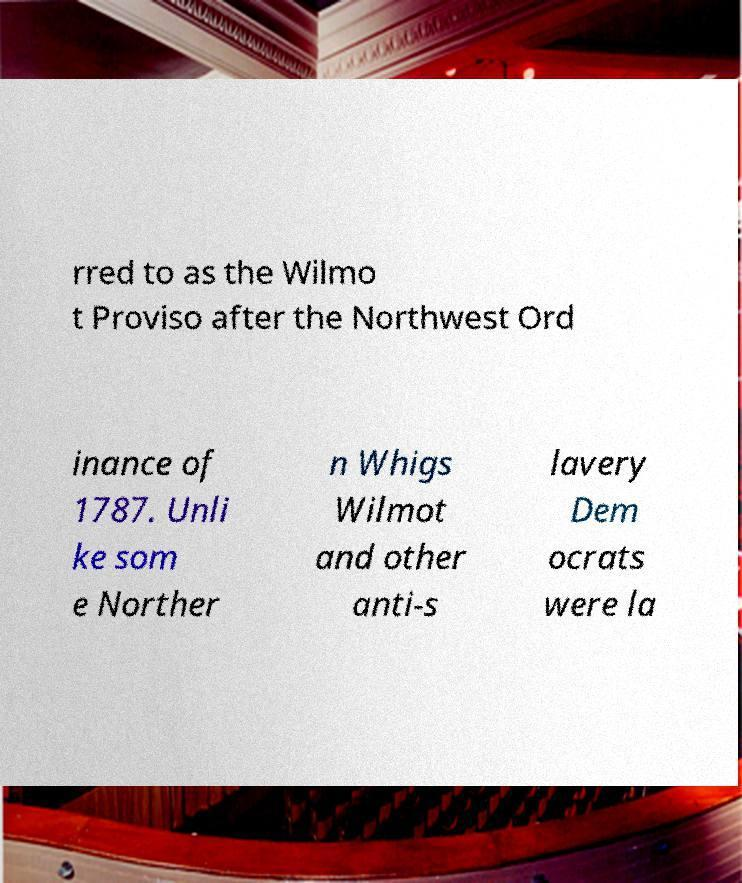I need the written content from this picture converted into text. Can you do that? rred to as the Wilmo t Proviso after the Northwest Ord inance of 1787. Unli ke som e Norther n Whigs Wilmot and other anti-s lavery Dem ocrats were la 